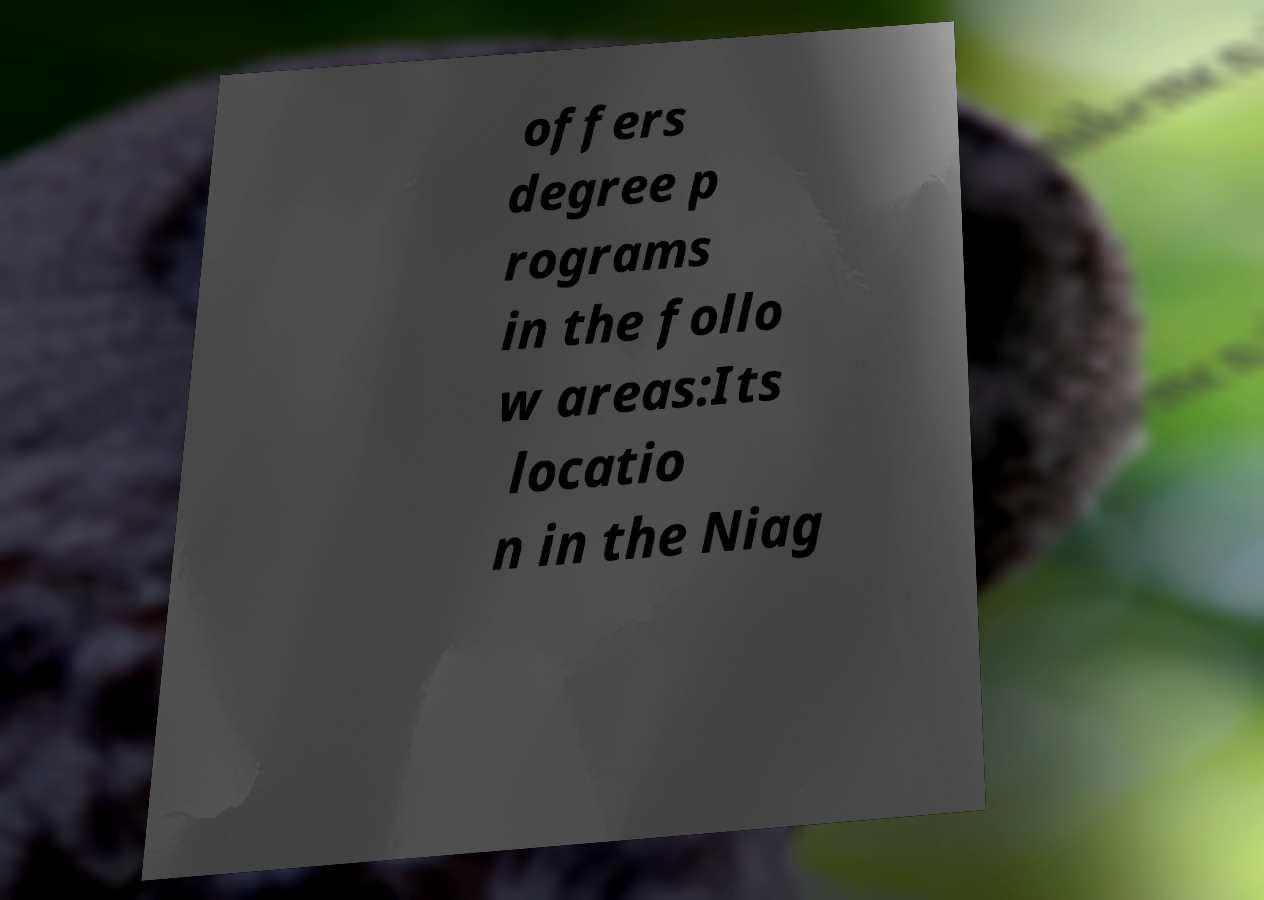Can you accurately transcribe the text from the provided image for me? offers degree p rograms in the follo w areas:Its locatio n in the Niag 